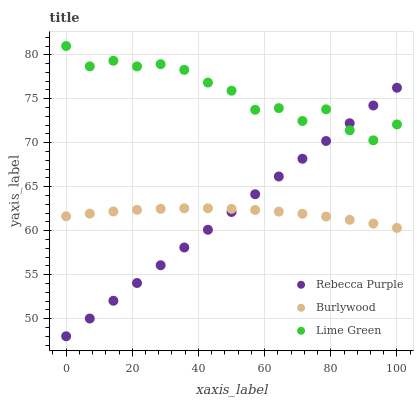Does Burlywood have the minimum area under the curve?
Answer yes or no. Yes. Does Lime Green have the maximum area under the curve?
Answer yes or no. Yes. Does Rebecca Purple have the minimum area under the curve?
Answer yes or no. No. Does Rebecca Purple have the maximum area under the curve?
Answer yes or no. No. Is Rebecca Purple the smoothest?
Answer yes or no. Yes. Is Lime Green the roughest?
Answer yes or no. Yes. Is Lime Green the smoothest?
Answer yes or no. No. Is Rebecca Purple the roughest?
Answer yes or no. No. Does Rebecca Purple have the lowest value?
Answer yes or no. Yes. Does Lime Green have the lowest value?
Answer yes or no. No. Does Lime Green have the highest value?
Answer yes or no. Yes. Does Rebecca Purple have the highest value?
Answer yes or no. No. Is Burlywood less than Lime Green?
Answer yes or no. Yes. Is Lime Green greater than Burlywood?
Answer yes or no. Yes. Does Rebecca Purple intersect Lime Green?
Answer yes or no. Yes. Is Rebecca Purple less than Lime Green?
Answer yes or no. No. Is Rebecca Purple greater than Lime Green?
Answer yes or no. No. Does Burlywood intersect Lime Green?
Answer yes or no. No. 